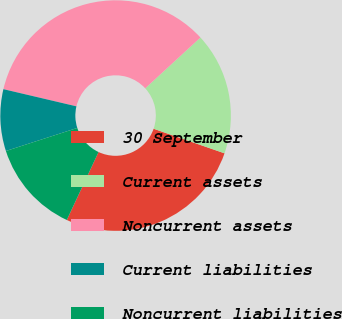Convert chart. <chart><loc_0><loc_0><loc_500><loc_500><pie_chart><fcel>30 September<fcel>Current assets<fcel>Noncurrent assets<fcel>Current liabilities<fcel>Noncurrent liabilities<nl><fcel>26.65%<fcel>17.15%<fcel>34.49%<fcel>8.65%<fcel>13.07%<nl></chart> 